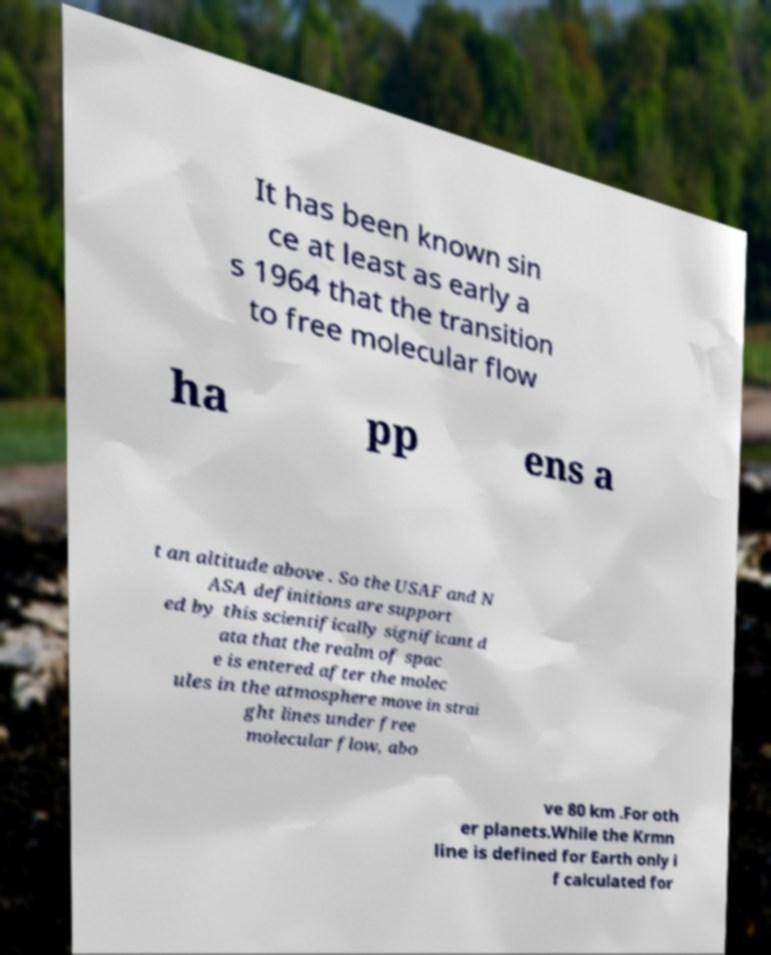Can you accurately transcribe the text from the provided image for me? It has been known sin ce at least as early a s 1964 that the transition to free molecular flow ha pp ens a t an altitude above . So the USAF and N ASA definitions are support ed by this scientifically significant d ata that the realm of spac e is entered after the molec ules in the atmosphere move in strai ght lines under free molecular flow, abo ve 80 km .For oth er planets.While the Krmn line is defined for Earth only i f calculated for 